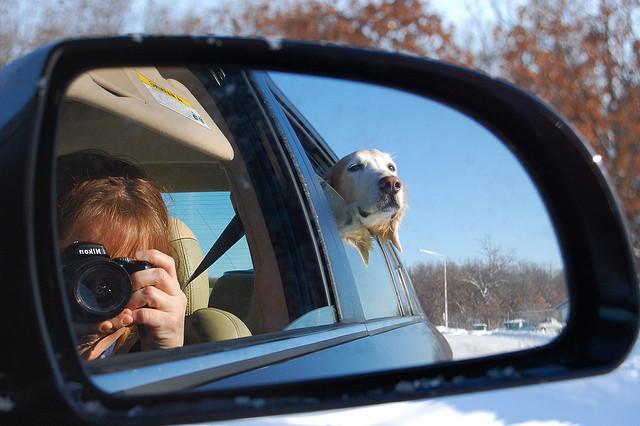Which lens used in side mirror of the car?

Choices:
A) macro
B) concave
C) convex
D) zoom convex 